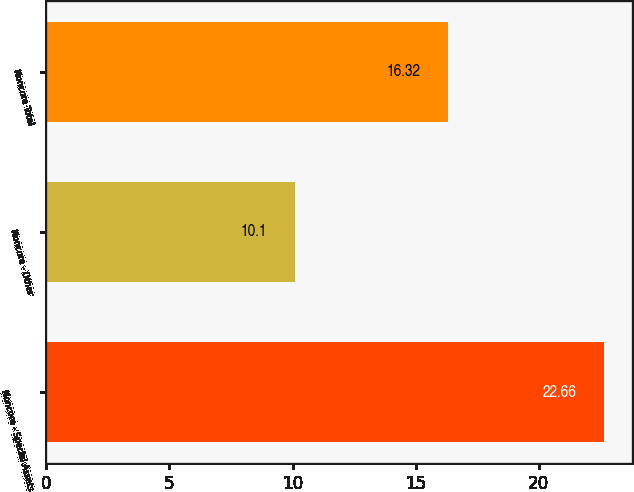<chart> <loc_0><loc_0><loc_500><loc_500><bar_chart><fcel>Noncore - Special Assets<fcel>Noncore - Other<fcel>Noncore Total<nl><fcel>22.66<fcel>10.1<fcel>16.32<nl></chart> 